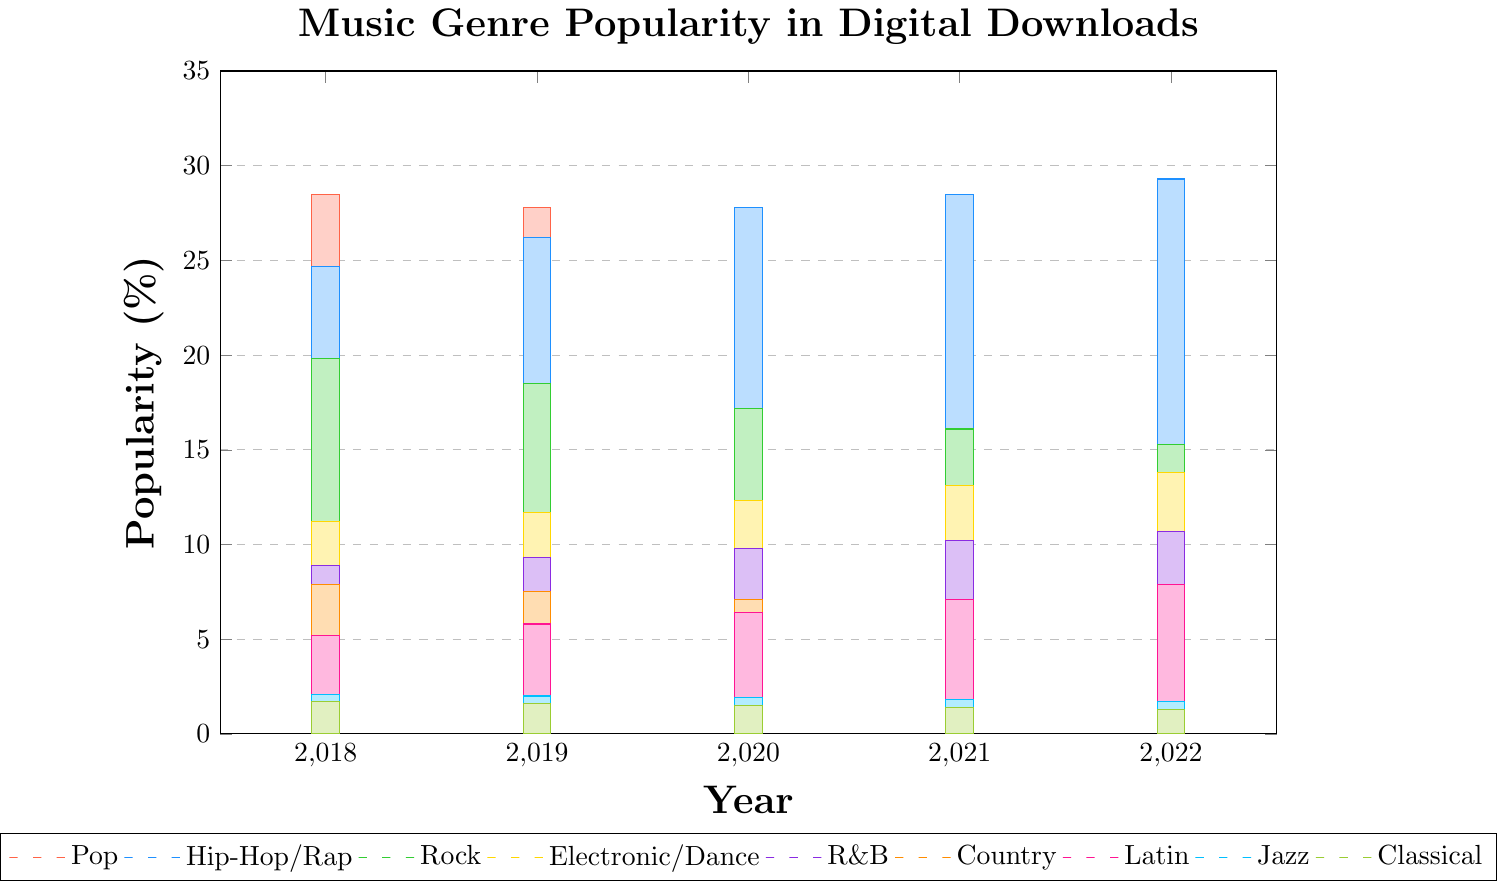Which genre has seen the most significant increase in popularity from 2018 to 2022? Look for the genre with the largest positive change between 2018 and 2022. Hip-Hop/Rap increased from 24.7% to 29.3%, an increase of 4.6%, compared to other genres which either increased less or decreased
Answer: Hip-Hop/Rap Which genre experienced the largest drop in popularity over the five years? Identify the genre with the largest negative change between 2018 and 2022. Pop decreased from 28.5% to 24.1%, a drop of 4.4%
Answer: Pop What is the average popularity of Rock music from 2018 to 2022? Sum the popularity values of Rock for each year and divide by the number of years: (19.8 + 18.5 + 17.2 + 16.1 + 15.3) / 5 = 17.38%
Answer: 17.38% In which year did the Latin music popularity surpass the Country music popularity? Compare the Latin and Country values for each year. In 2021, Latin (7.1%) surpassed Country (6.8%) popularity
Answer: 2021 What is the overall trend in popularity for Electronic/Dance music over the past five years? Observe the data points for Electronic/Dance from 2018 to 2022. The values have been steadily increasing from 11.2% to 13.8%
Answer: Increasing Which genres have decreased in popularity every year from 2018 to 2022? Check the yearly data for each genre to see if the values continually decrease. Pop, Rock, Jazz, and Classical all show a yearly decline
Answer: Pop, Rock, Jazz, Classical In 2020, how much more popular was Hip-Hop/Rap than Rock? Subtract the Rock value from the Hip-Hop/Rap value for 2020: 27.8% - 17.2% = 10.6%
Answer: 10.6% Which genre is represented by the green bar? Identify the genre based on the description color of the green bar. Rock is represented by the green bar
Answer: Rock Among Pop and R&B, which genre had a higher popularity average between 2018 and 2022? Calculate the average for both Pop and R&B, compare the two. Pop: (28.5 + 27.8 + 26.9 + 25.4 + 24.1) / 5 = 26.54%. R&B: (8.9 + 9.3 + 9.8 + 10.2 + 10.7) / 5 = 9.78%
Answer: Pop Out of the genres listed, which one had the lowest popularity in 2022? Look for the genre with the smallest value in 2022. Classical had the lowest popularity with 1.3%
Answer: Classical 